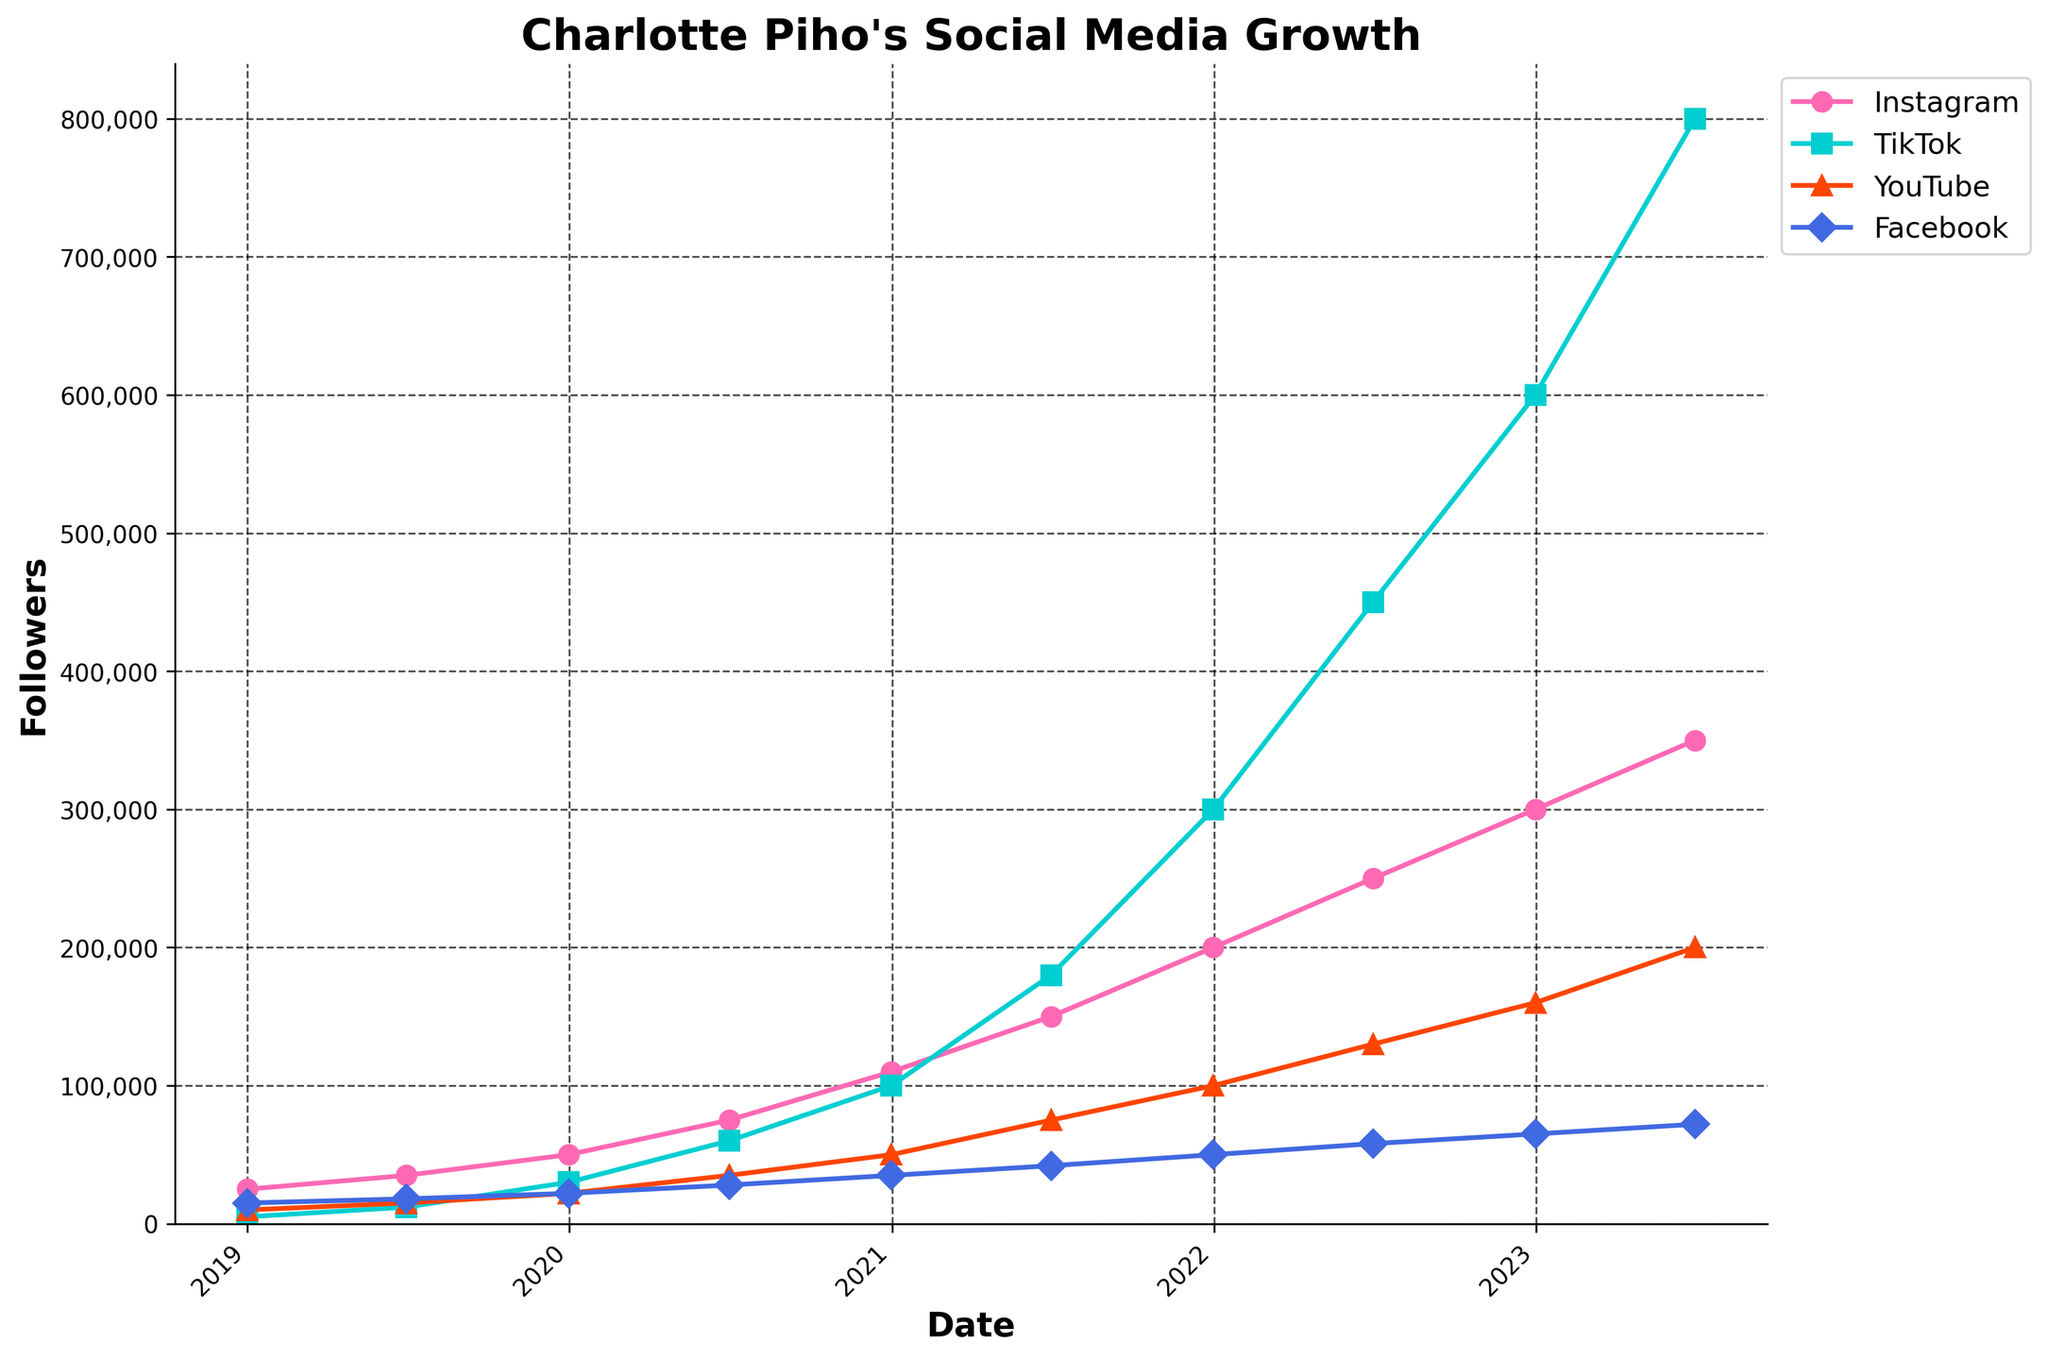What is the total number of TikTok followers by mid-2021? Look at the plot's line for TikTok and find the point corresponding to mid-year 2021, which should be around June. Check the y-axis value for that point.
Answer: 180,000 Between which two dates did Instagram followers increase the most? Examine the Instagram line and observe the segments with the steepest upward slope. Compare the slopes between various segments to determine which one has the most significant increase.
Answer: December 2021 - June 2022 What was the difference between TikTok and YouTube followers at the end of 2022? Locate the data points for TikTok and YouTube at the end of 2022. Subtract the number of YouTube followers from the number of TikTok followers.
Answer: 440,000 By how many followers did Charlotte Piho's Facebook followers grow between 2019 and 2023? Identify the Facebook followers at the start of 2019 and at mid-2023. Subtract the earlier value from the later value.
Answer: 22,000 Which platform had the least number of followers at the end of 2020? Compare the number of followers for each platform at the end of 2020 and look for the platform with the smallest value.
Answer: Facebook How many times more followers did TikTok have compared to Facebook by mid-2023? Locate the values for TikTok and Facebook followers by mid-2023. Divide the number of TikTok followers by the number of Facebook followers.
Answer: 11.1 (rounded to one decimal place) Which platform reached 100,000 followers first, and when? Check the growth lines for each platform and find the first instance each crosses the 100,000 mark, noting which platform and the date.
Answer: TikTok, December 2020 By how much did YouTube followers increase between the start of 2019 and the end of 2021? Identify the YouTube followers at the start of 2019 and the end of 2021. Subtract the initial value from the later value.
Answer: 90,000 How does the growth rate of TikTok followers compare to that of Instagram from mid-2020 to end of 2020? Calculate the increase in followers for both TikTok and Instagram between mid-2020 and end of 2020. Compare the differences in these follower counts.
Answer: TikTok increased by 40,000, Instagram increased by 35,000. TikTok had a higher growth rate Which platform experienced the smallest growth in followers throughout the entire period? Determine the total growth for each platform by subtracting the initial follower count (start of 2019) from the final count (mid-2023) for each platform. Compare these values to find the smallest.
Answer: Facebook 